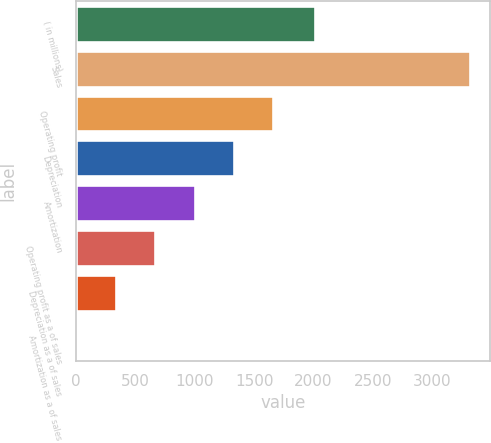<chart> <loc_0><loc_0><loc_500><loc_500><bar_chart><fcel>( in millions)<fcel>Sales<fcel>Operating profit<fcel>Depreciation<fcel>Amortization<fcel>Operating profit as a of sales<fcel>Depreciation as a of sales<fcel>Amortization as a of sales<nl><fcel>2015<fcel>3323<fcel>1662.05<fcel>1329.86<fcel>997.67<fcel>665.48<fcel>333.29<fcel>1.1<nl></chart> 